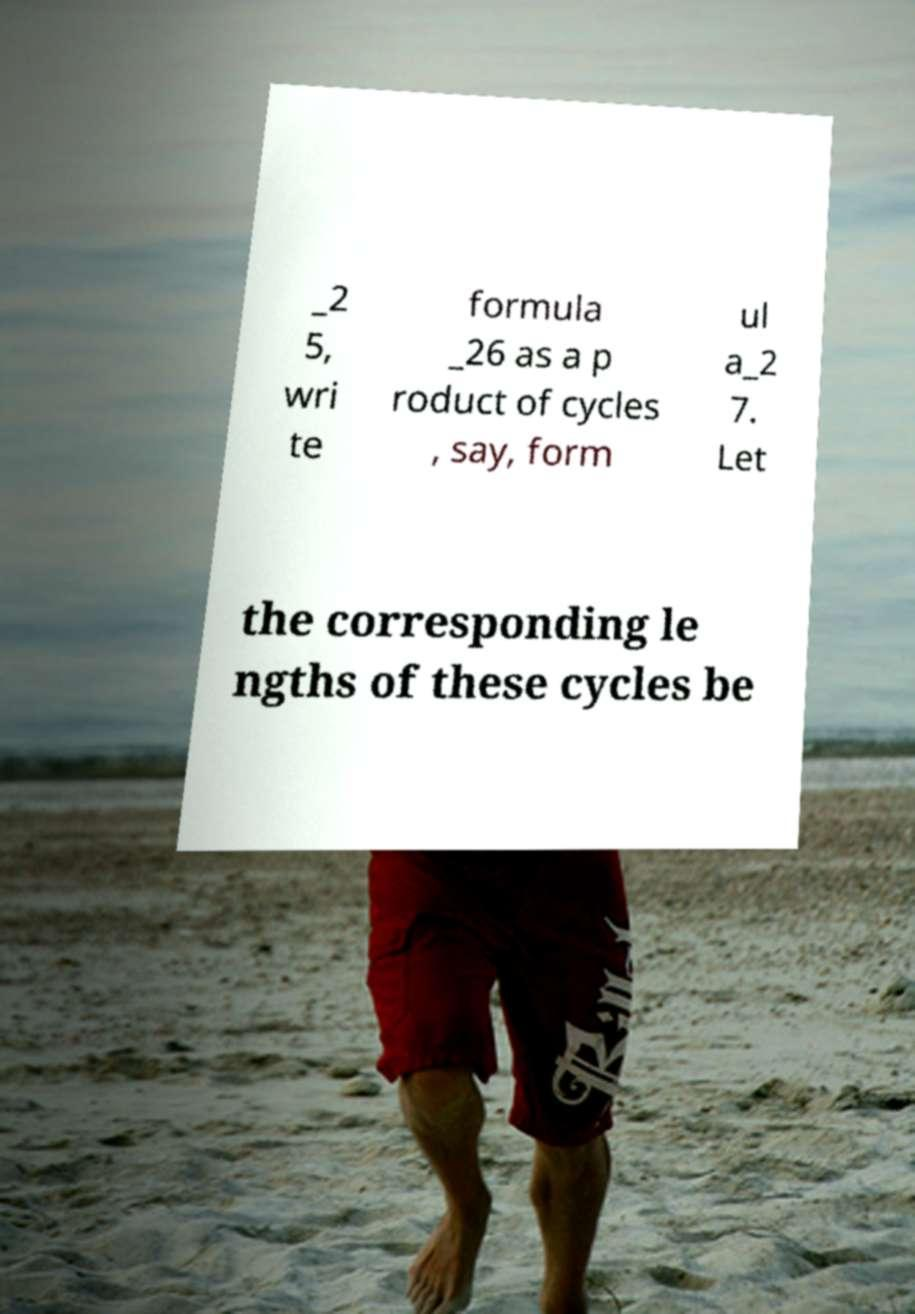Could you assist in decoding the text presented in this image and type it out clearly? _2 5, wri te formula _26 as a p roduct of cycles , say, form ul a_2 7. Let the corresponding le ngths of these cycles be 